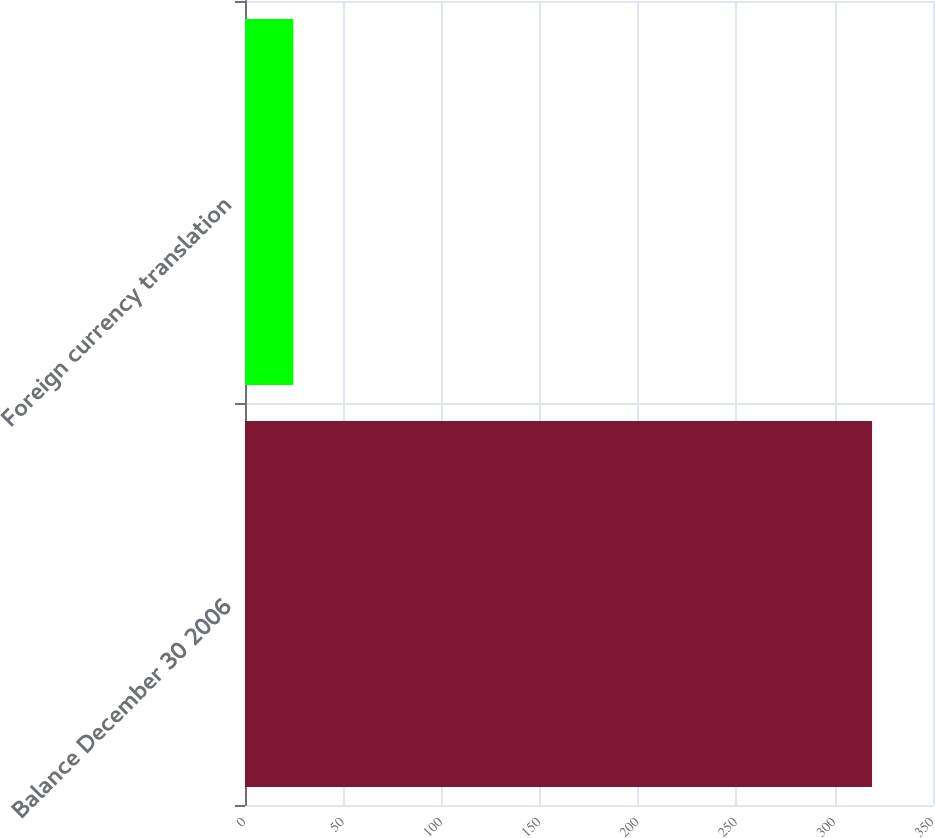Convert chart to OTSL. <chart><loc_0><loc_0><loc_500><loc_500><bar_chart><fcel>Balance December 30 2006<fcel>Foreign currency translation<nl><fcel>319<fcel>24.6<nl></chart> 